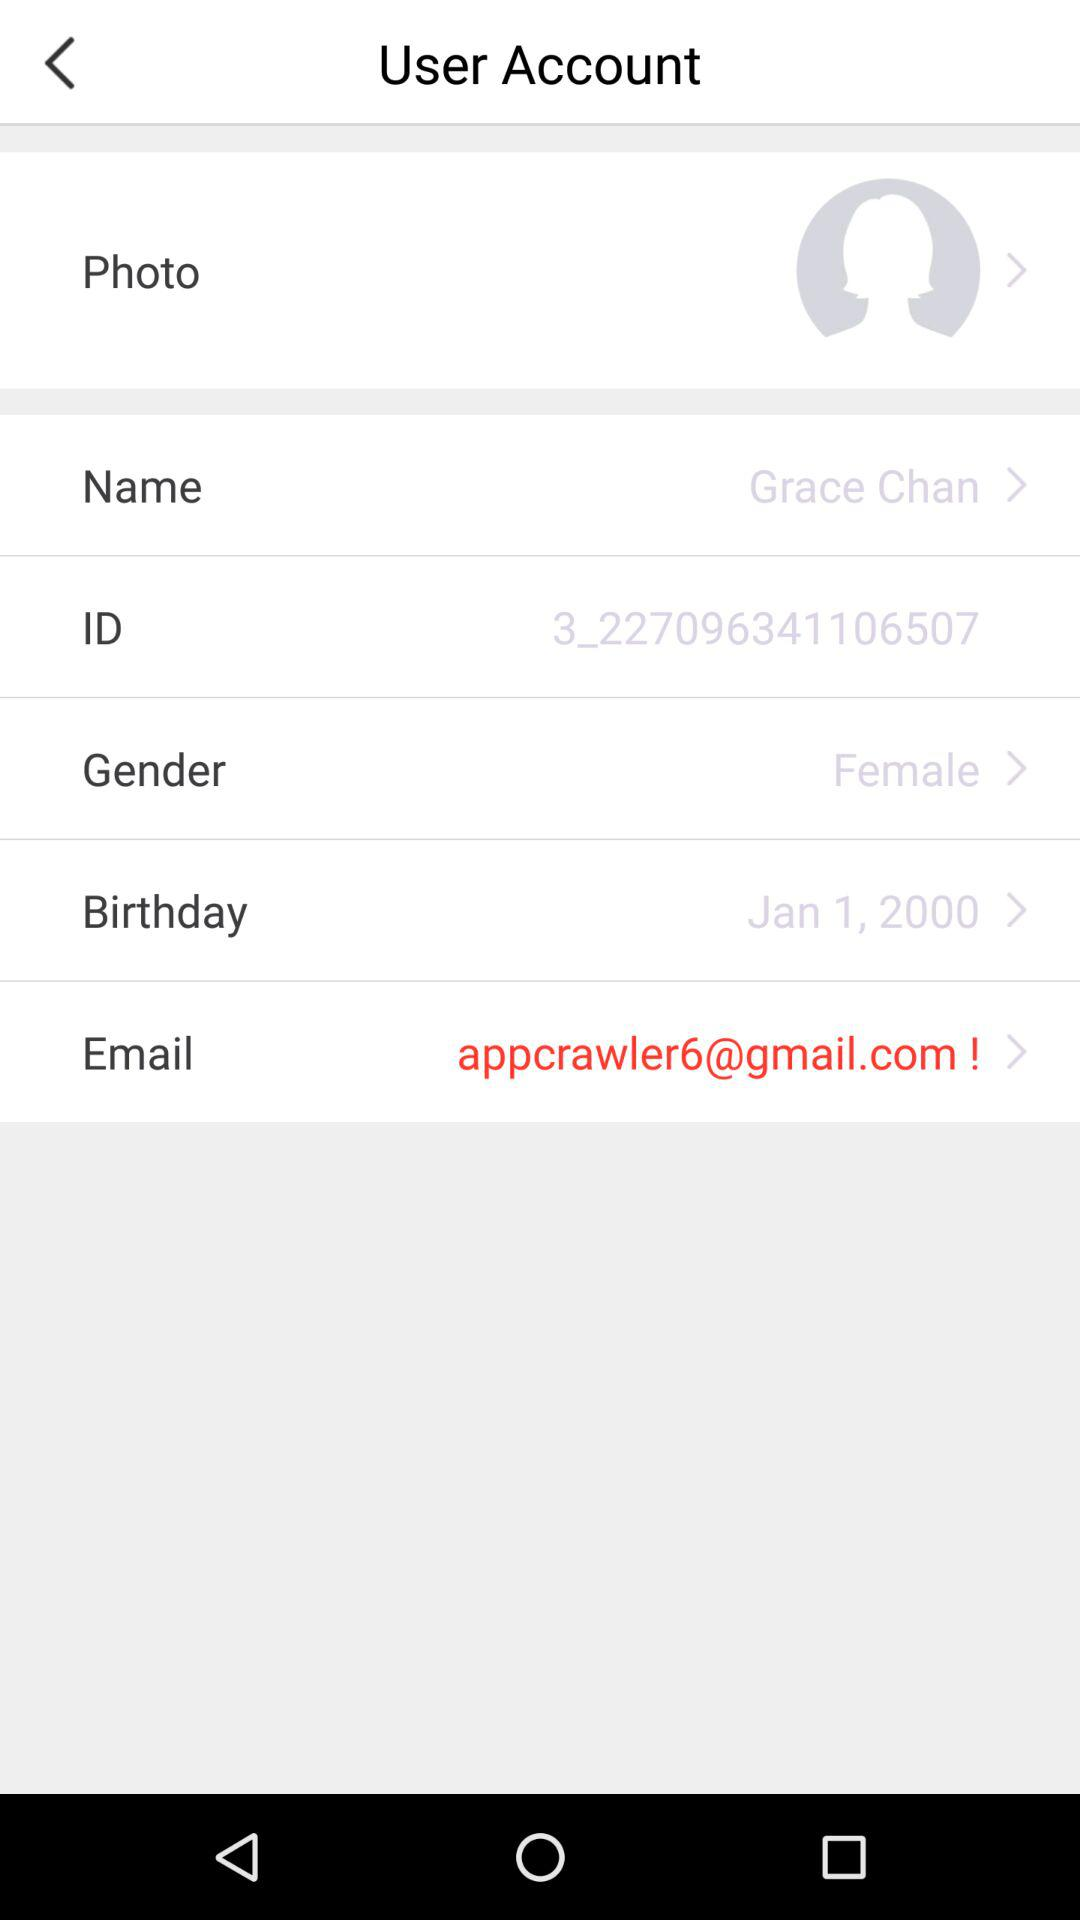What is the name? The name is Grace Chan. 